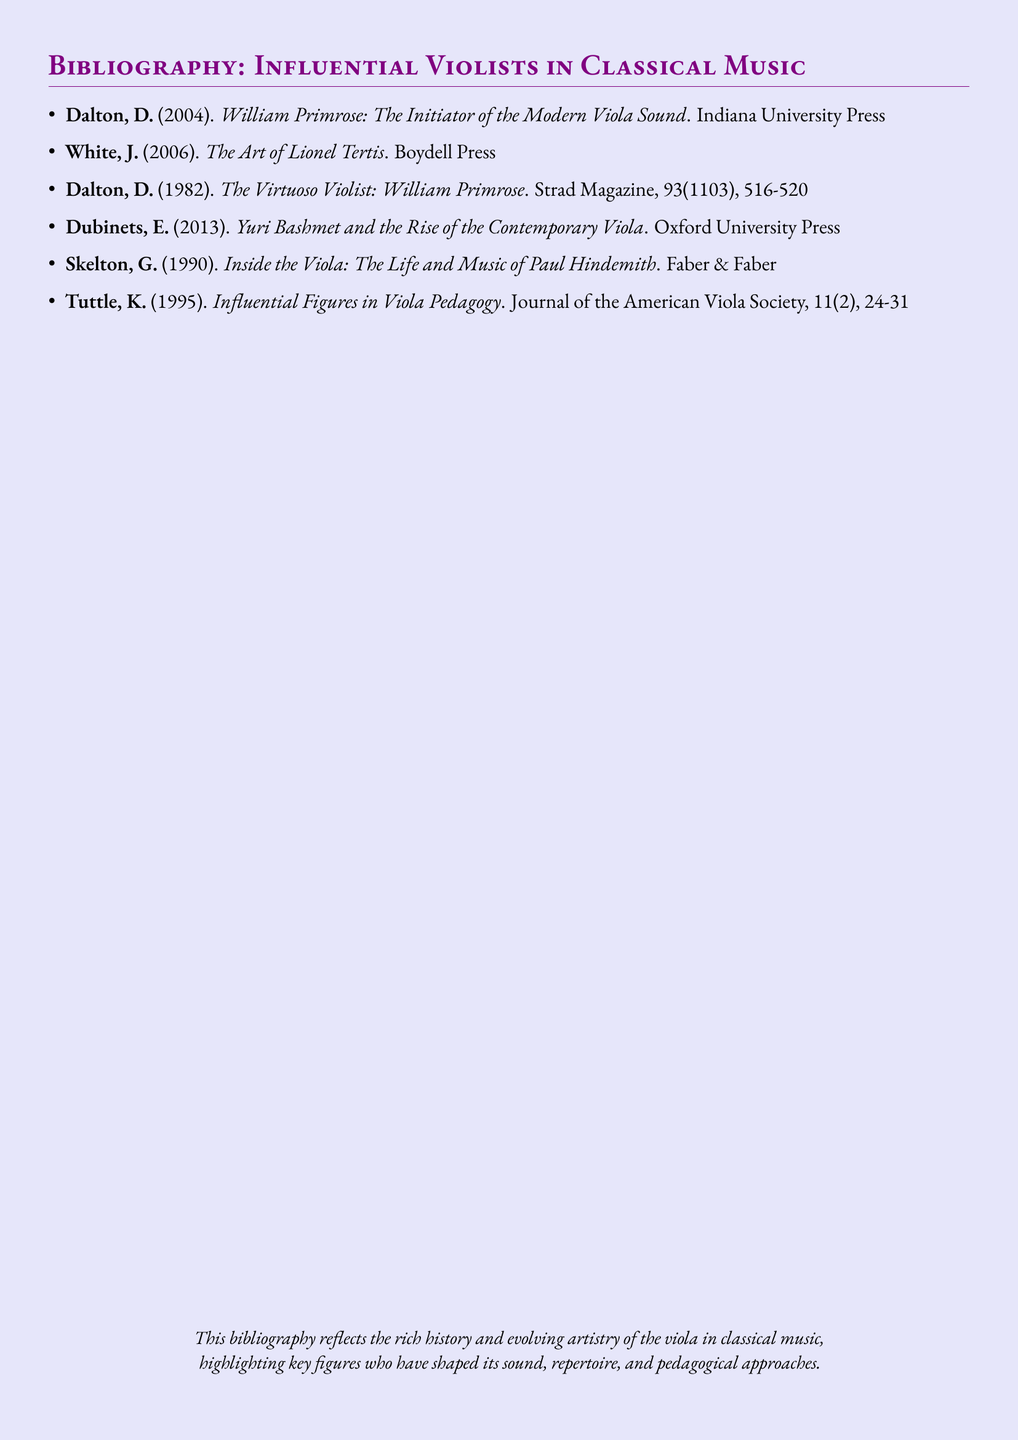What is the title of Dalton's 2004 book? The title of the book is specified in the bibliography entry for Dalton, D. (2004).
Answer: William Primrose: The Initiator of the Modern Viola Sound Who published "The Art of Lionel Tertis"? The name of the publisher for the work by White, J. (2006) is listed.
Answer: Boydell Press In what year was "Influential Figures in Viola Pedagogy" published? The publication year is explicitly noted in the bibliography entry for Tuttle, K. (1995).
Answer: 1995 How many entries are there in the bibliography? The total number of entries can be counted based on the items listed.
Answer: 6 Which violist's life and music is discussed by Skelton? The name of the violist featured in Skelton's work is found in the title of the entry.
Answer: Paul Hindemith What journal featured Dalton's 1982 article? The journal is mentioned in the bibliography entry.
Answer: Strad Magazine Who discussed Yuri Bashmet's impact on the contemporary viola? The author of the entry that discusses Yuri Bashmet is identified in the bibliography.
Answer: Dubinets, E What color is used for the page background? The document metadata states the background color used throughout the text.
Answer: Lavender 